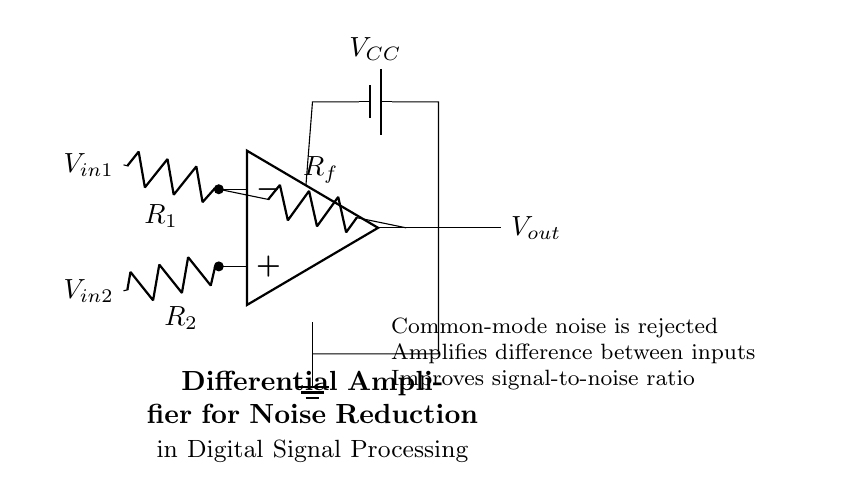What is the role of the resistors R1 and R2? R1 and R2 serve as input resistors that set the gain and influence how the differential amplifier responds to the input signals V_in1 and V_in2. They determine the amplifier's differential gain.
Answer: Input resistors What is the purpose of the feedback resistor Rf? The feedback resistor Rf creates a feedback loop in the amplifier which stabilizes the gain by providing a portion of the output back to the inverting input. This helps to control the output based on the difference between the input signals.
Answer: Feedback stabilization What does V_out represent? V_out represents the output voltage of the differential amplifier after processing the input signals V_in1 and V_in2. It reflects the amplified difference between these two inputs.
Answer: Output voltage What kind of noise reduction is achieved by this circuit? The circuit filters out common-mode noise, allowing it to only amplify the difference in the input signals while reducing unwanted noise that affects both inputs equally.
Answer: Common-mode noise How does this amplifier improve the signal-to-noise ratio? By rejecting common-mode noise and amplifying only the difference between the input signals, the circuit increases the signal's prominence relative to noise, enhancing overall clarity and quality.
Answer: Increased clarity What is the voltage supply to the circuit? The voltage supply indicated in the circuit is V_CC, which powers the operational amplifier to ensure it operates correctly and can handle the input signals effectively.
Answer: Voltage supply 